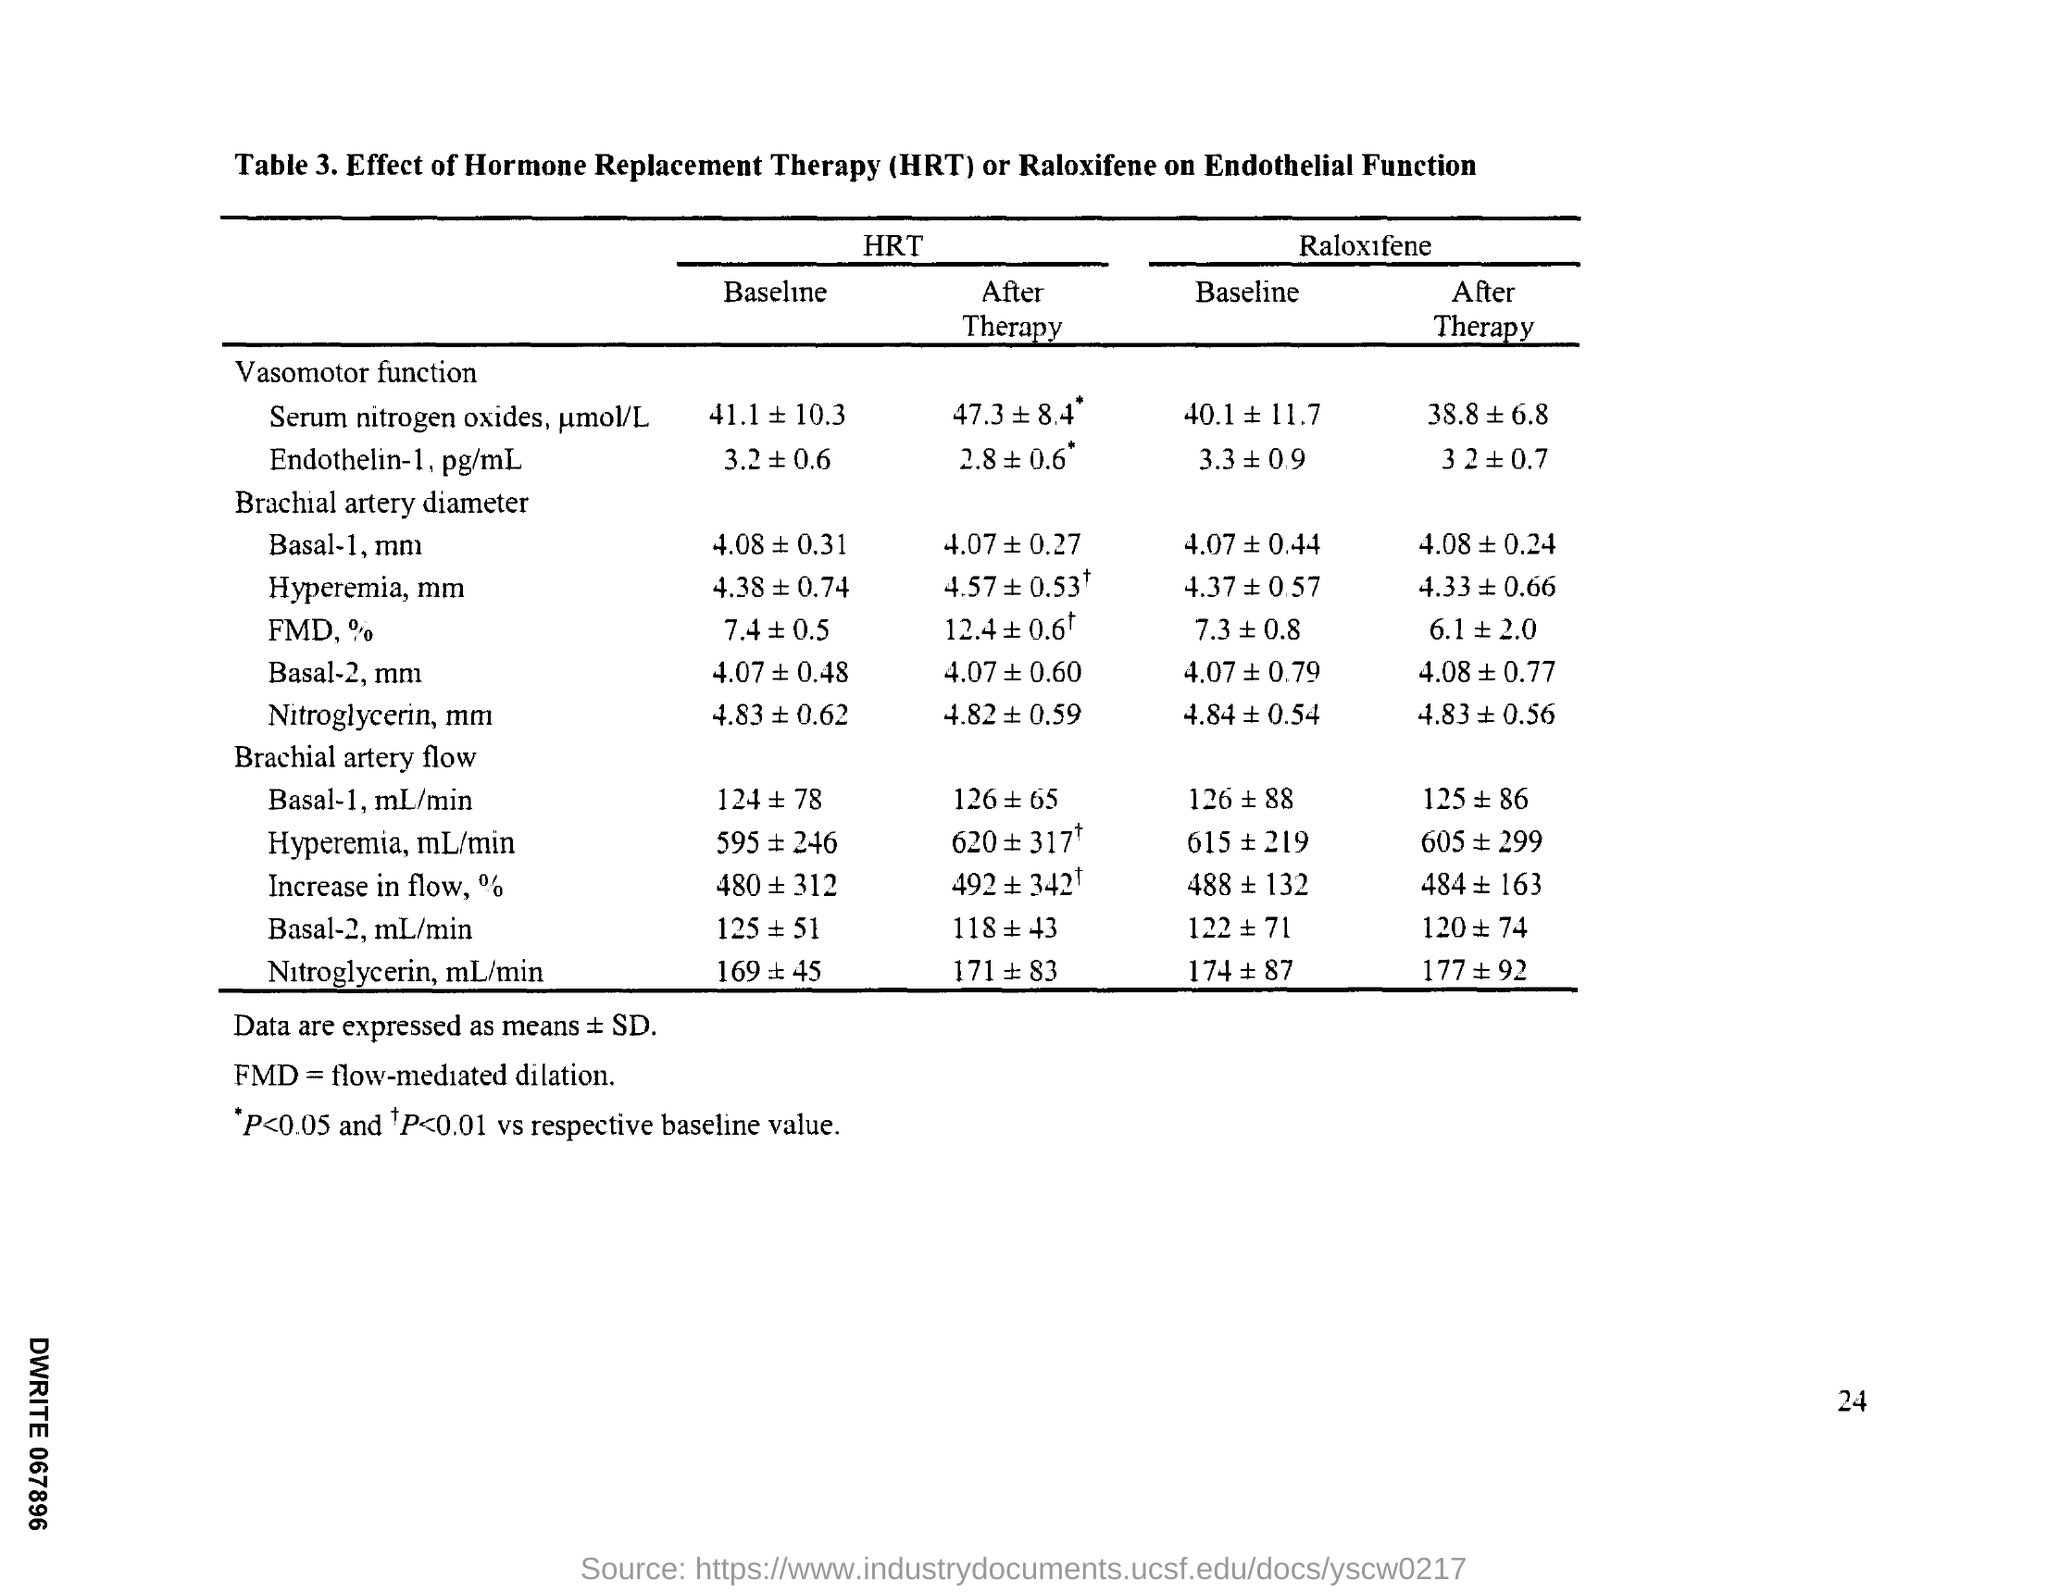Indicate a few pertinent items in this graphic. HRT stands for hormone replacement therapy, a medical treatment that involves replacing hormones that are no longer produced in the body with the goal of relieving symptoms of hormonal imbalance. 